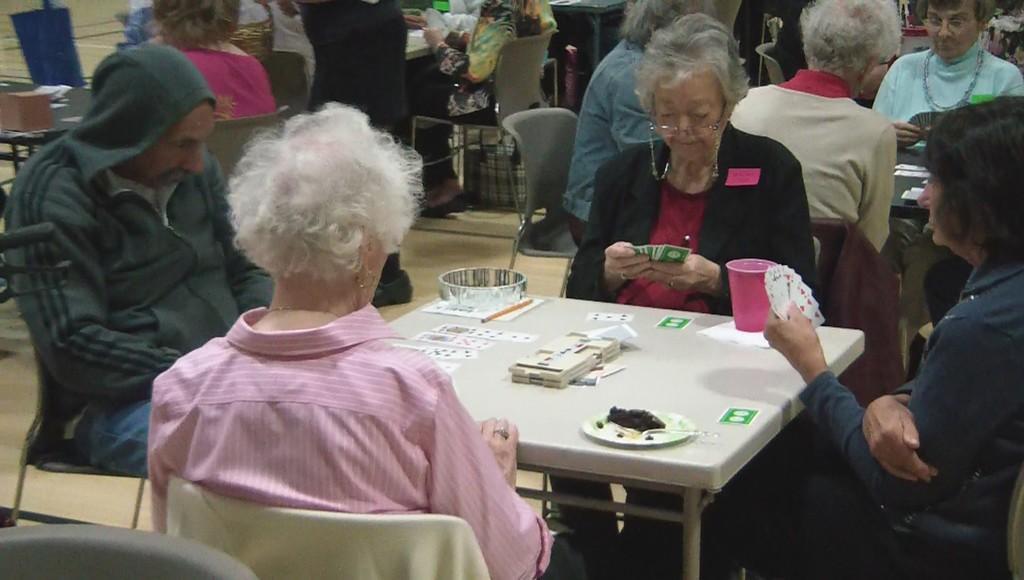Please provide a concise description of this image. In this image, there are group of people sitting on the chair in front of the table and playing cards. On the table cards, plate, food and glass is kept. It looks as if the picture is taken inside the club during sunny day. 